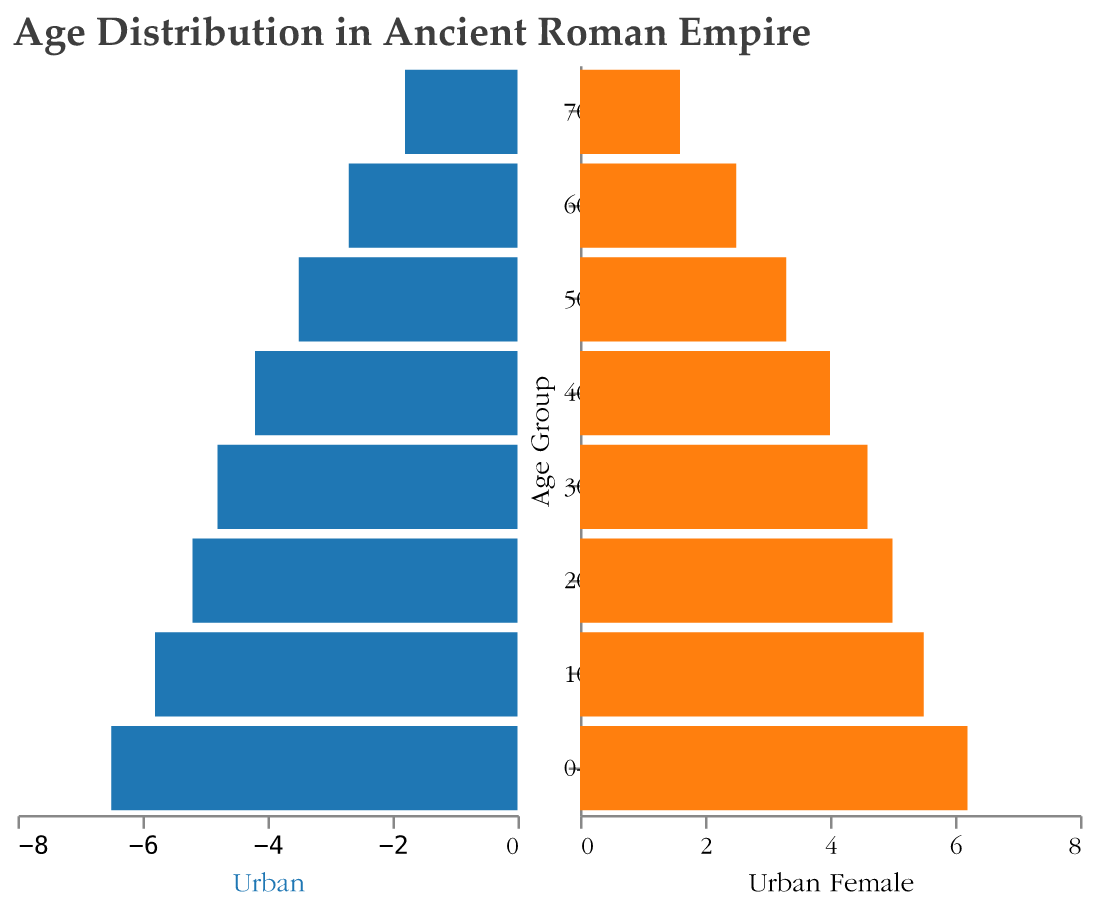what is the title of the figure? The title of the figure is often located at the top of the plot, identifying the subject of the data visualized. Here, it is "Age Distribution in Ancient Roman Empire" as specified in the code.
Answer: Age Distribution in Ancient Roman Empire Which age group has the highest percentage of the urban male population? The highest bar on the left side of the urban male section of the population pyramid visually indicates the age group with the highest percentage. Here, the age group 0-9 shows the highest percentage (6.5%).
Answer: 0-9 Among rural populations, which gender has a higher percentage in the 20-29 age group? Look at the heights of the bars for rural males and females in the 20-29 age group. The rural male percentage is 6.5%, and rural female is 6.2%, making rural males higher for this age group.
Answer: Rural males What is the combined percentage of urban population aged 30-39 years for both males and females? To find the combined percentage for both genders in the urban 30-39 age group, sum the values for males (4.8%) and females (4.6%). Therefore, 4.8 + 4.6 = 9.4%.
Answer: 9.4% How does the percentage of urban females aged 60-69 compare to rural females in the same age group? Compare the bar lengths of urban and rural females within the 60-69 age group. The urban female percentage is 2.5%, while the rural female percentage is 2.8%. The rural females are higher.
Answer: Rural females higher What's the difference between urban and rural male populations in the 0-9 age group? Subtract the urban male percentage (6.5%) from the rural male percentage (7.8%). Thus, 7.8 - 6.5 = 1.3%.
Answer: 1.3% What is the gender distribution trend for the urban population across different age groups? Observing the population pyramid, urban males generally start with a higher percentage in younger age groups and gradually decrease as age increases. Urban females follow a similar trend with slightly lower percentages in each age group.
Answer: Decreasing trend Which age group has the smallest percentage difference between urban males and females? Examine each age group's urban male and female percentages and calculate the differences. The smallest difference occurs in the 20-29 age group: 5.2% - 5.0% = 0.2%.
Answer: 20-29 How much larger is the rural male population compared to the urban male population in the age group 50-59? Subtract the urban male percentage (3.5%) from the rural male percentage (4.2%). Thus, 4.2 - 3.5 = 0.7%.
Answer: 0.7% 